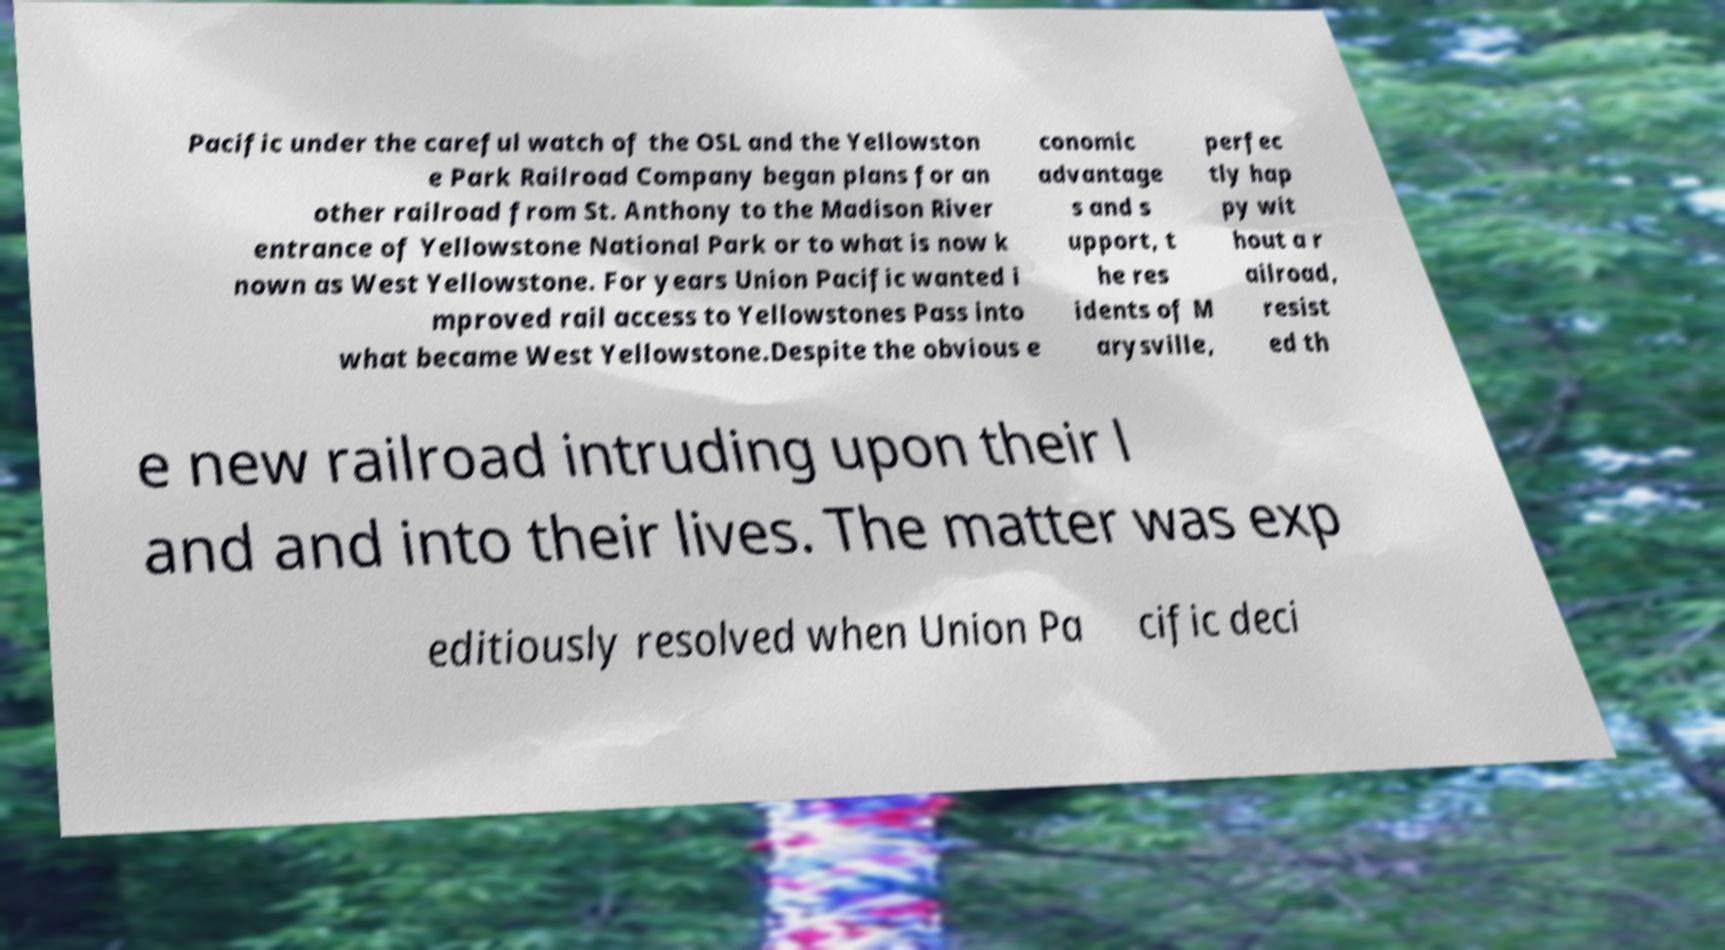I need the written content from this picture converted into text. Can you do that? Pacific under the careful watch of the OSL and the Yellowston e Park Railroad Company began plans for an other railroad from St. Anthony to the Madison River entrance of Yellowstone National Park or to what is now k nown as West Yellowstone. For years Union Pacific wanted i mproved rail access to Yellowstones Pass into what became West Yellowstone.Despite the obvious e conomic advantage s and s upport, t he res idents of M arysville, perfec tly hap py wit hout a r ailroad, resist ed th e new railroad intruding upon their l and and into their lives. The matter was exp editiously resolved when Union Pa cific deci 